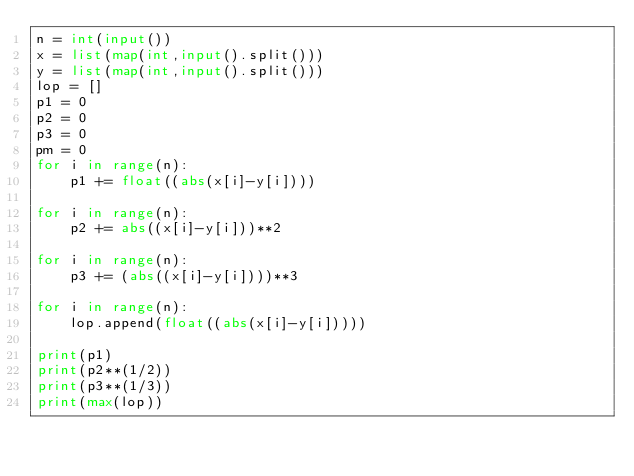<code> <loc_0><loc_0><loc_500><loc_500><_Python_>n = int(input())
x = list(map(int,input().split()))
y = list(map(int,input().split()))
lop = []
p1 = 0
p2 = 0
p3 = 0
pm = 0
for i in range(n):
    p1 += float((abs(x[i]-y[i])))
    
for i in range(n):
    p2 += abs((x[i]-y[i]))**2
    
for i in range(n):
    p3 += (abs((x[i]-y[i])))**3
    
for i in range(n):
    lop.append(float((abs(x[i]-y[i]))))
    
print(p1)
print(p2**(1/2))
print(p3**(1/3))
print(max(lop))
</code> 